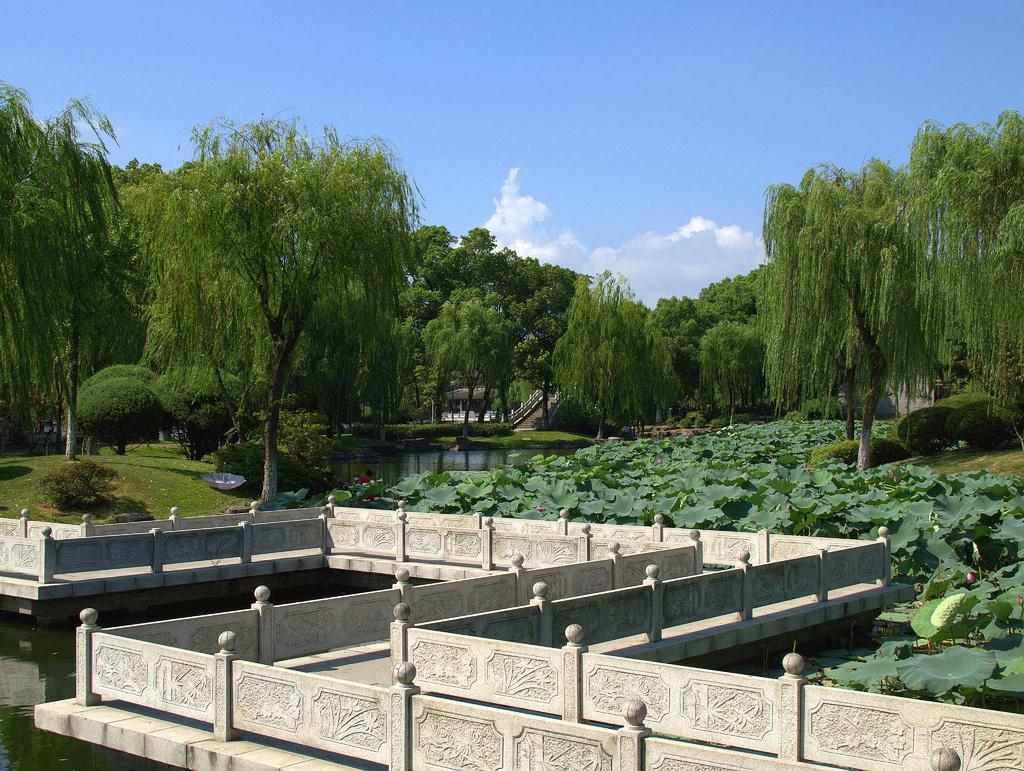Can you describe this image briefly? In this picture I can see there is a bridge, there is a bridge, with plants and there is grass, plants, trees and it looks like there is a building in the backdrop and the sky is clear. 